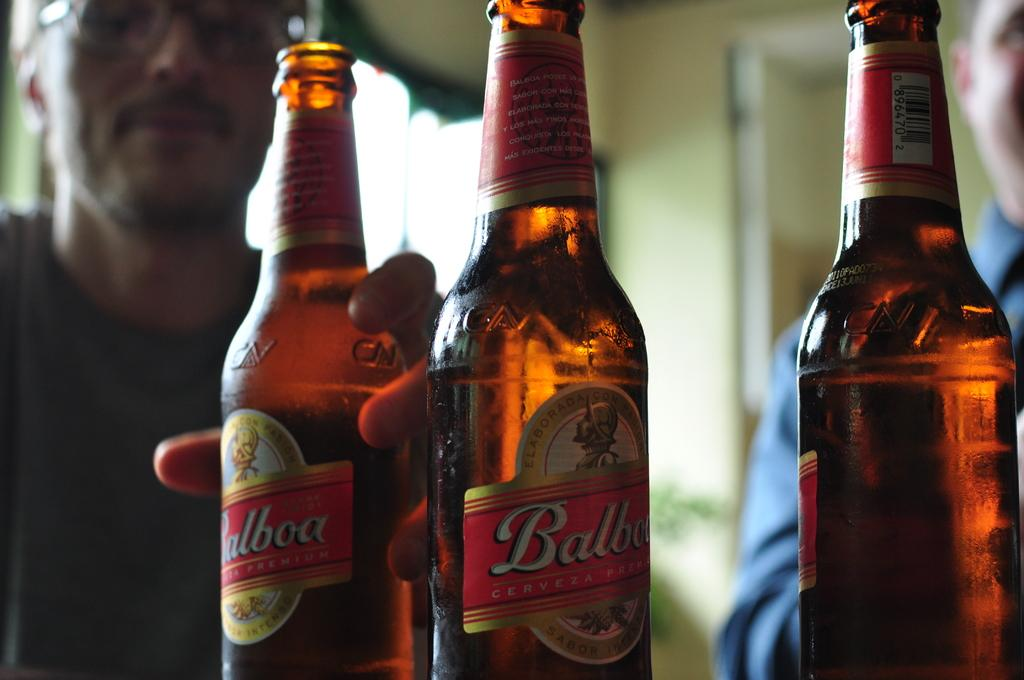Who is present in the image? There is a man in the image. What is the man holding in the image? The man is holding a beer bottle. How many beer bottles are visible in the image? There are three beer bottles in the image. What can be seen on the labels of the beer bottles? The beer bottles have a label with the name "Barboa". What type of experience does the man have in the library in the image? There is no library present in the image, so it is not possible to determine any experiences related to a library. 